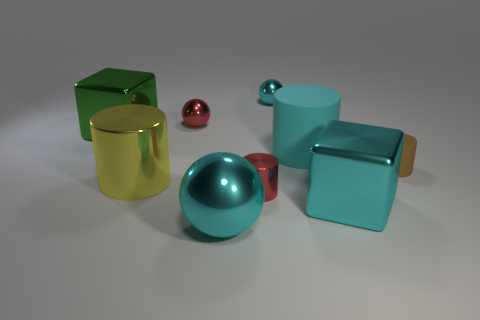There is a large sphere that is the same color as the large rubber object; what material is it?
Offer a terse response. Metal. There is a metallic block that is the same color as the large rubber cylinder; what is its size?
Provide a succinct answer. Large. Is the color of the metallic block that is left of the tiny cyan metallic ball the same as the block that is in front of the large rubber cylinder?
Keep it short and to the point. No. Are there any matte things of the same color as the big matte cylinder?
Offer a very short reply. No. What number of other things are there of the same shape as the yellow thing?
Provide a succinct answer. 3. The large metal thing behind the cyan cylinder has what shape?
Your answer should be compact. Cube. There is a green shiny thing; is its shape the same as the small object on the right side of the tiny cyan ball?
Your answer should be compact. No. What is the size of the cylinder that is both behind the yellow shiny object and in front of the cyan cylinder?
Offer a terse response. Small. There is a small object that is both in front of the large cyan matte cylinder and on the left side of the cyan metallic cube; what color is it?
Give a very brief answer. Red. Is there anything else that has the same material as the big cyan ball?
Keep it short and to the point. Yes. 